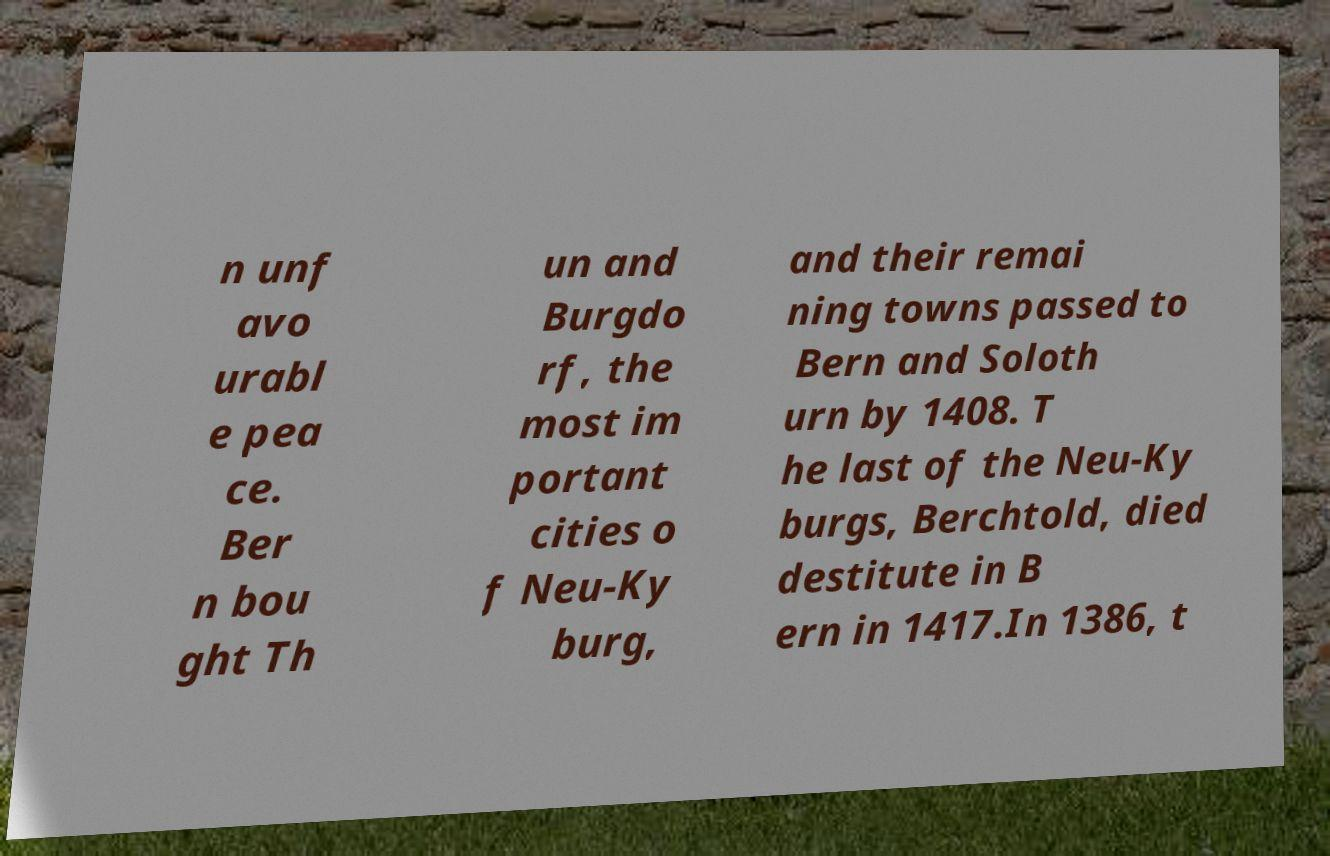There's text embedded in this image that I need extracted. Can you transcribe it verbatim? n unf avo urabl e pea ce. Ber n bou ght Th un and Burgdo rf, the most im portant cities o f Neu-Ky burg, and their remai ning towns passed to Bern and Soloth urn by 1408. T he last of the Neu-Ky burgs, Berchtold, died destitute in B ern in 1417.In 1386, t 